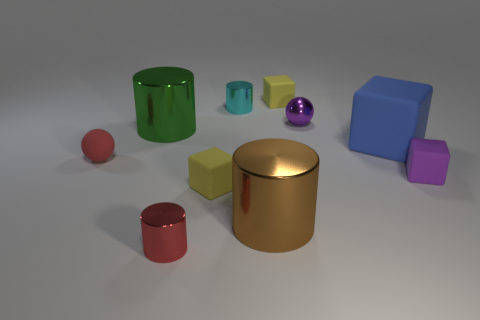Subtract all purple blocks. How many blocks are left? 3 Subtract all gray cylinders. Subtract all brown spheres. How many cylinders are left? 4 Subtract all balls. How many objects are left? 8 Add 4 red spheres. How many red spheres are left? 5 Add 3 big cylinders. How many big cylinders exist? 5 Subtract 1 purple blocks. How many objects are left? 9 Subtract all tiny red metallic cylinders. Subtract all red matte objects. How many objects are left? 8 